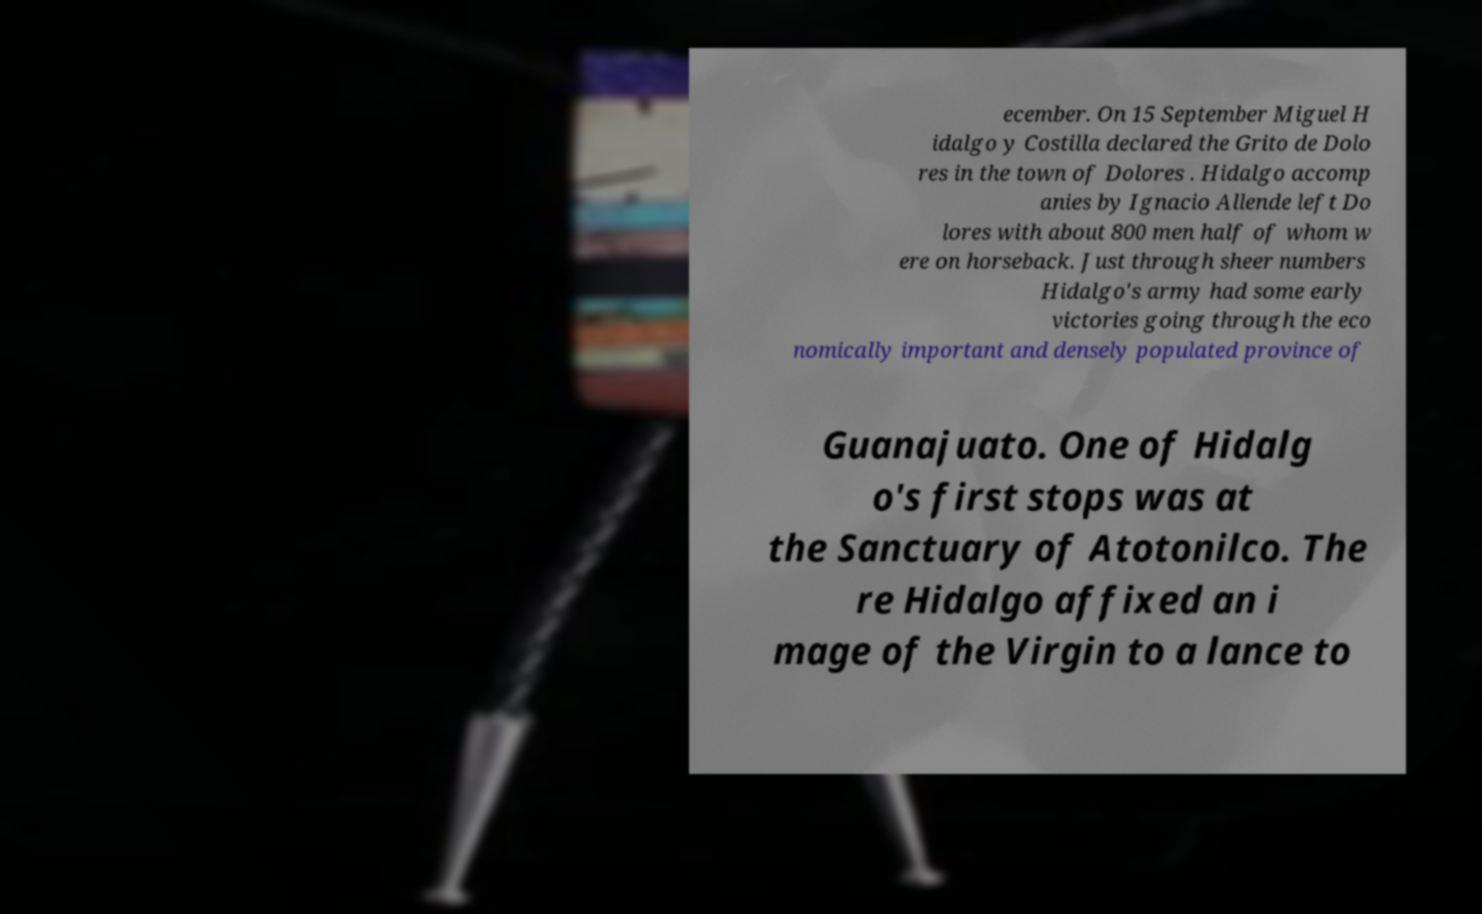Please identify and transcribe the text found in this image. ecember. On 15 September Miguel H idalgo y Costilla declared the Grito de Dolo res in the town of Dolores . Hidalgo accomp anies by Ignacio Allende left Do lores with about 800 men half of whom w ere on horseback. Just through sheer numbers Hidalgo's army had some early victories going through the eco nomically important and densely populated province of Guanajuato. One of Hidalg o's first stops was at the Sanctuary of Atotonilco. The re Hidalgo affixed an i mage of the Virgin to a lance to 